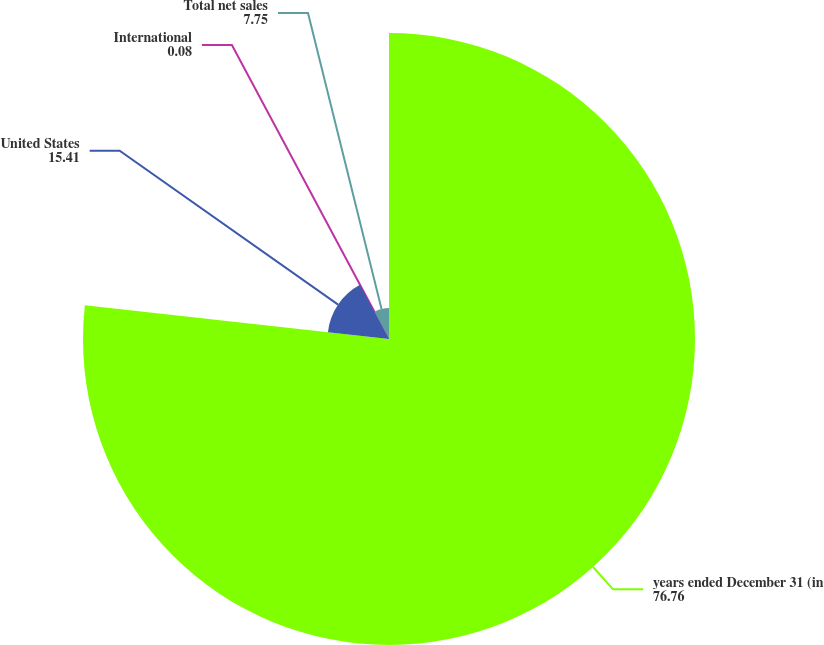Convert chart. <chart><loc_0><loc_0><loc_500><loc_500><pie_chart><fcel>years ended December 31 (in<fcel>United States<fcel>International<fcel>Total net sales<nl><fcel>76.76%<fcel>15.41%<fcel>0.08%<fcel>7.75%<nl></chart> 